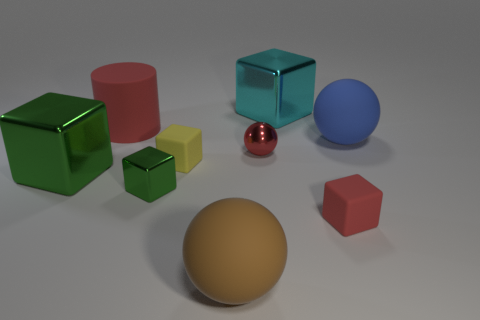Subtract all red matte cubes. How many cubes are left? 4 Subtract all cyan blocks. How many blocks are left? 4 Subtract all red spheres. How many green blocks are left? 2 Subtract 3 cubes. How many cubes are left? 2 Add 1 yellow cubes. How many objects exist? 10 Subtract all blocks. How many objects are left? 4 Subtract all purple cylinders. Subtract all cyan cubes. How many cylinders are left? 1 Subtract all tiny blocks. Subtract all small matte things. How many objects are left? 4 Add 9 metal spheres. How many metal spheres are left? 10 Add 6 cyan matte cylinders. How many cyan matte cylinders exist? 6 